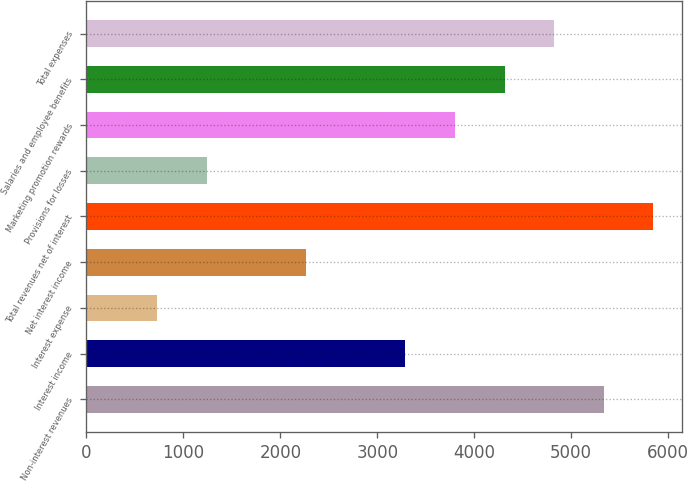Convert chart. <chart><loc_0><loc_0><loc_500><loc_500><bar_chart><fcel>Non-interest revenues<fcel>Interest income<fcel>Interest expense<fcel>Net interest income<fcel>Total revenues net of interest<fcel>Provisions for losses<fcel>Marketing promotion rewards<fcel>Salaries and employee benefits<fcel>Total expenses<nl><fcel>5337<fcel>3290.2<fcel>731.7<fcel>2266.8<fcel>5848.7<fcel>1243.4<fcel>3801.9<fcel>4313.6<fcel>4825.3<nl></chart> 